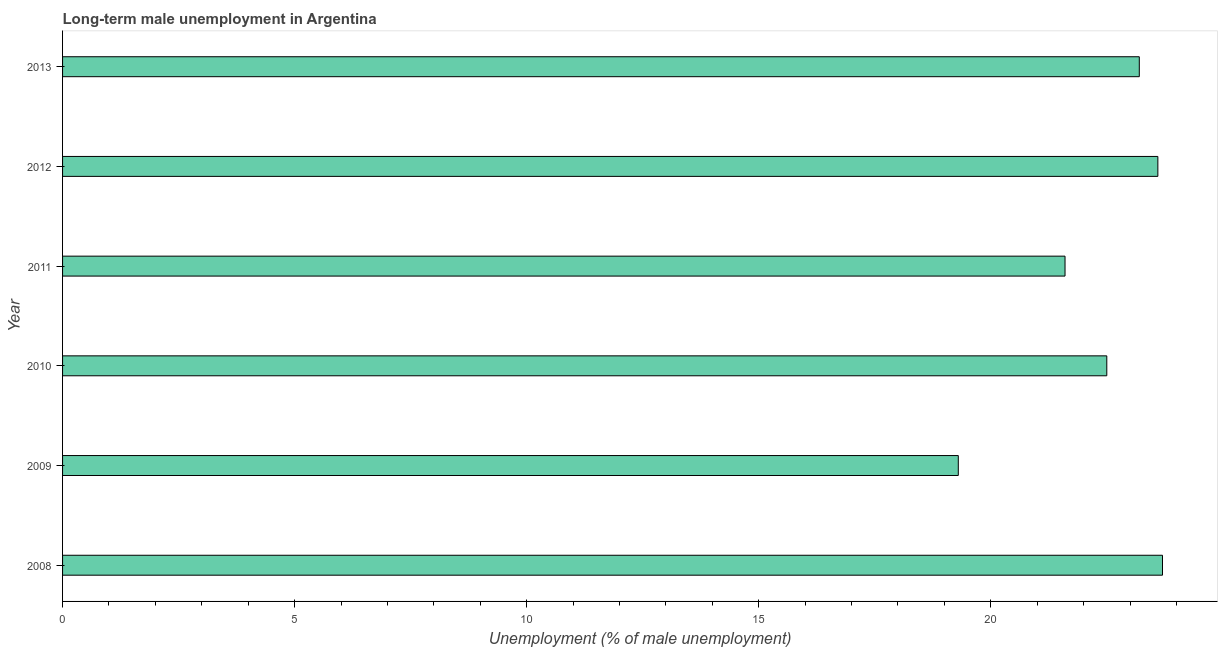Does the graph contain any zero values?
Give a very brief answer. No. What is the title of the graph?
Keep it short and to the point. Long-term male unemployment in Argentina. What is the label or title of the X-axis?
Your answer should be compact. Unemployment (% of male unemployment). What is the long-term male unemployment in 2012?
Your answer should be very brief. 23.6. Across all years, what is the maximum long-term male unemployment?
Make the answer very short. 23.7. Across all years, what is the minimum long-term male unemployment?
Your answer should be compact. 19.3. What is the sum of the long-term male unemployment?
Ensure brevity in your answer.  133.9. What is the average long-term male unemployment per year?
Your answer should be compact. 22.32. What is the median long-term male unemployment?
Ensure brevity in your answer.  22.85. In how many years, is the long-term male unemployment greater than 5 %?
Your answer should be very brief. 6. Do a majority of the years between 2011 and 2012 (inclusive) have long-term male unemployment greater than 18 %?
Your answer should be compact. Yes. What is the ratio of the long-term male unemployment in 2009 to that in 2012?
Your answer should be very brief. 0.82. Is the long-term male unemployment in 2008 less than that in 2013?
Your response must be concise. No. Is the sum of the long-term male unemployment in 2010 and 2011 greater than the maximum long-term male unemployment across all years?
Provide a short and direct response. Yes. What is the difference between the highest and the lowest long-term male unemployment?
Your answer should be very brief. 4.4. In how many years, is the long-term male unemployment greater than the average long-term male unemployment taken over all years?
Offer a very short reply. 4. How many bars are there?
Give a very brief answer. 6. How many years are there in the graph?
Offer a terse response. 6. What is the difference between two consecutive major ticks on the X-axis?
Ensure brevity in your answer.  5. What is the Unemployment (% of male unemployment) of 2008?
Offer a terse response. 23.7. What is the Unemployment (% of male unemployment) of 2009?
Provide a succinct answer. 19.3. What is the Unemployment (% of male unemployment) of 2010?
Provide a succinct answer. 22.5. What is the Unemployment (% of male unemployment) of 2011?
Your answer should be very brief. 21.6. What is the Unemployment (% of male unemployment) of 2012?
Ensure brevity in your answer.  23.6. What is the Unemployment (% of male unemployment) of 2013?
Your response must be concise. 23.2. What is the difference between the Unemployment (% of male unemployment) in 2008 and 2009?
Give a very brief answer. 4.4. What is the difference between the Unemployment (% of male unemployment) in 2008 and 2010?
Provide a short and direct response. 1.2. What is the difference between the Unemployment (% of male unemployment) in 2008 and 2013?
Your answer should be very brief. 0.5. What is the difference between the Unemployment (% of male unemployment) in 2009 and 2011?
Ensure brevity in your answer.  -2.3. What is the difference between the Unemployment (% of male unemployment) in 2009 and 2012?
Offer a terse response. -4.3. What is the difference between the Unemployment (% of male unemployment) in 2010 and 2011?
Make the answer very short. 0.9. What is the difference between the Unemployment (% of male unemployment) in 2011 and 2012?
Provide a succinct answer. -2. What is the difference between the Unemployment (% of male unemployment) in 2012 and 2013?
Keep it short and to the point. 0.4. What is the ratio of the Unemployment (% of male unemployment) in 2008 to that in 2009?
Your response must be concise. 1.23. What is the ratio of the Unemployment (% of male unemployment) in 2008 to that in 2010?
Your response must be concise. 1.05. What is the ratio of the Unemployment (% of male unemployment) in 2008 to that in 2011?
Provide a short and direct response. 1.1. What is the ratio of the Unemployment (% of male unemployment) in 2009 to that in 2010?
Your response must be concise. 0.86. What is the ratio of the Unemployment (% of male unemployment) in 2009 to that in 2011?
Offer a terse response. 0.89. What is the ratio of the Unemployment (% of male unemployment) in 2009 to that in 2012?
Give a very brief answer. 0.82. What is the ratio of the Unemployment (% of male unemployment) in 2009 to that in 2013?
Keep it short and to the point. 0.83. What is the ratio of the Unemployment (% of male unemployment) in 2010 to that in 2011?
Give a very brief answer. 1.04. What is the ratio of the Unemployment (% of male unemployment) in 2010 to that in 2012?
Your answer should be compact. 0.95. What is the ratio of the Unemployment (% of male unemployment) in 2011 to that in 2012?
Offer a terse response. 0.92. What is the ratio of the Unemployment (% of male unemployment) in 2011 to that in 2013?
Your response must be concise. 0.93. 